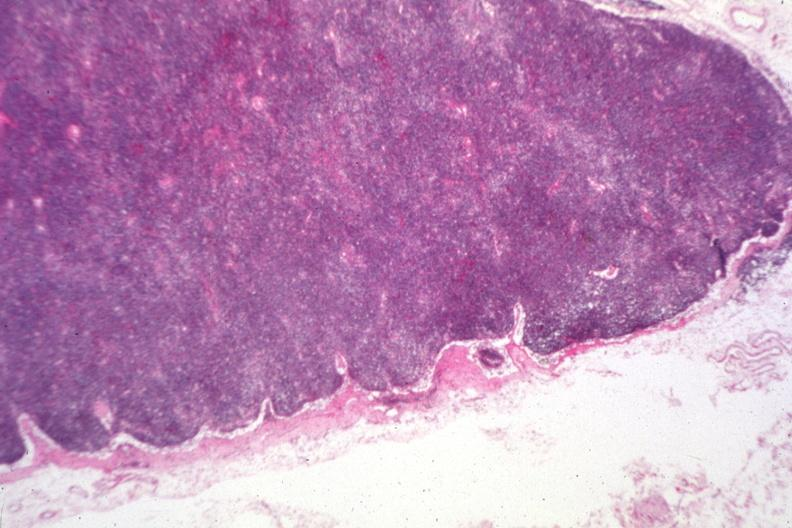s child present?
Answer the question using a single word or phrase. No 